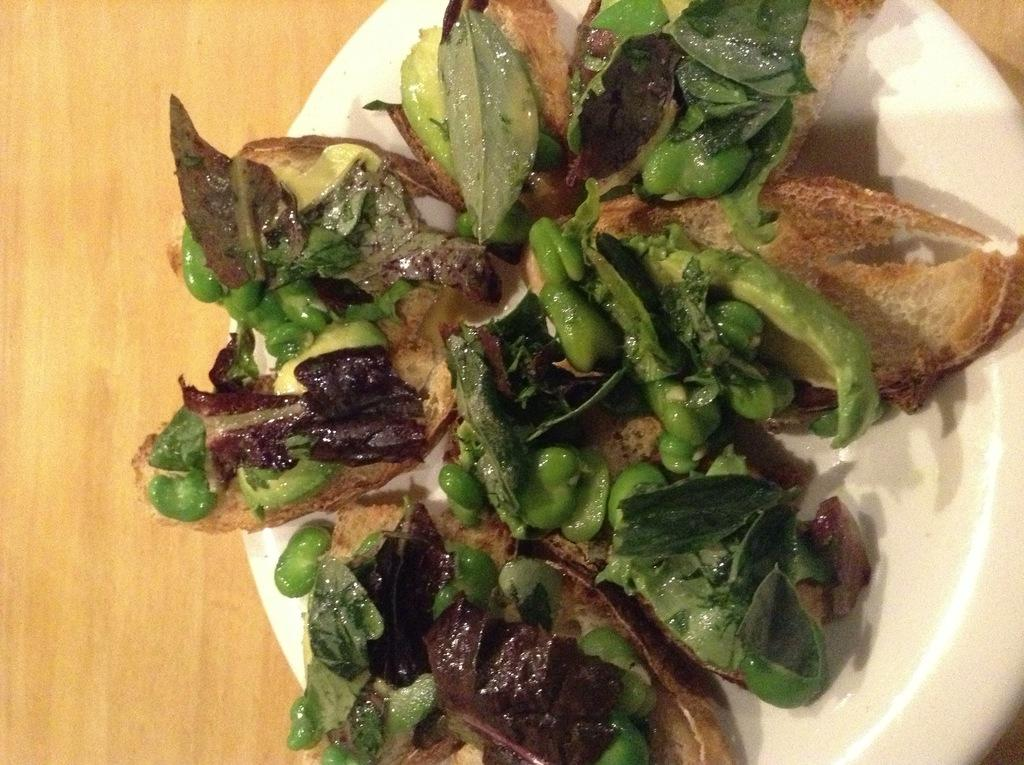What object is present in the image that typically holds food? There is a plate in the image that typically holds food. What is on the plate in the image? The plate contains food. What type of farm animals can be seen grazing on the plate in the image? There are no farm animals present in the image, as it only contains a plate with food. 